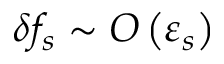<formula> <loc_0><loc_0><loc_500><loc_500>\delta f _ { s } \sim O \left ( \varepsilon _ { s } \right )</formula> 